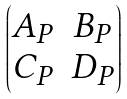Convert formula to latex. <formula><loc_0><loc_0><loc_500><loc_500>\begin{pmatrix} A _ { P } & B _ { P } \\ C _ { P } & D _ { P } \end{pmatrix}</formula> 